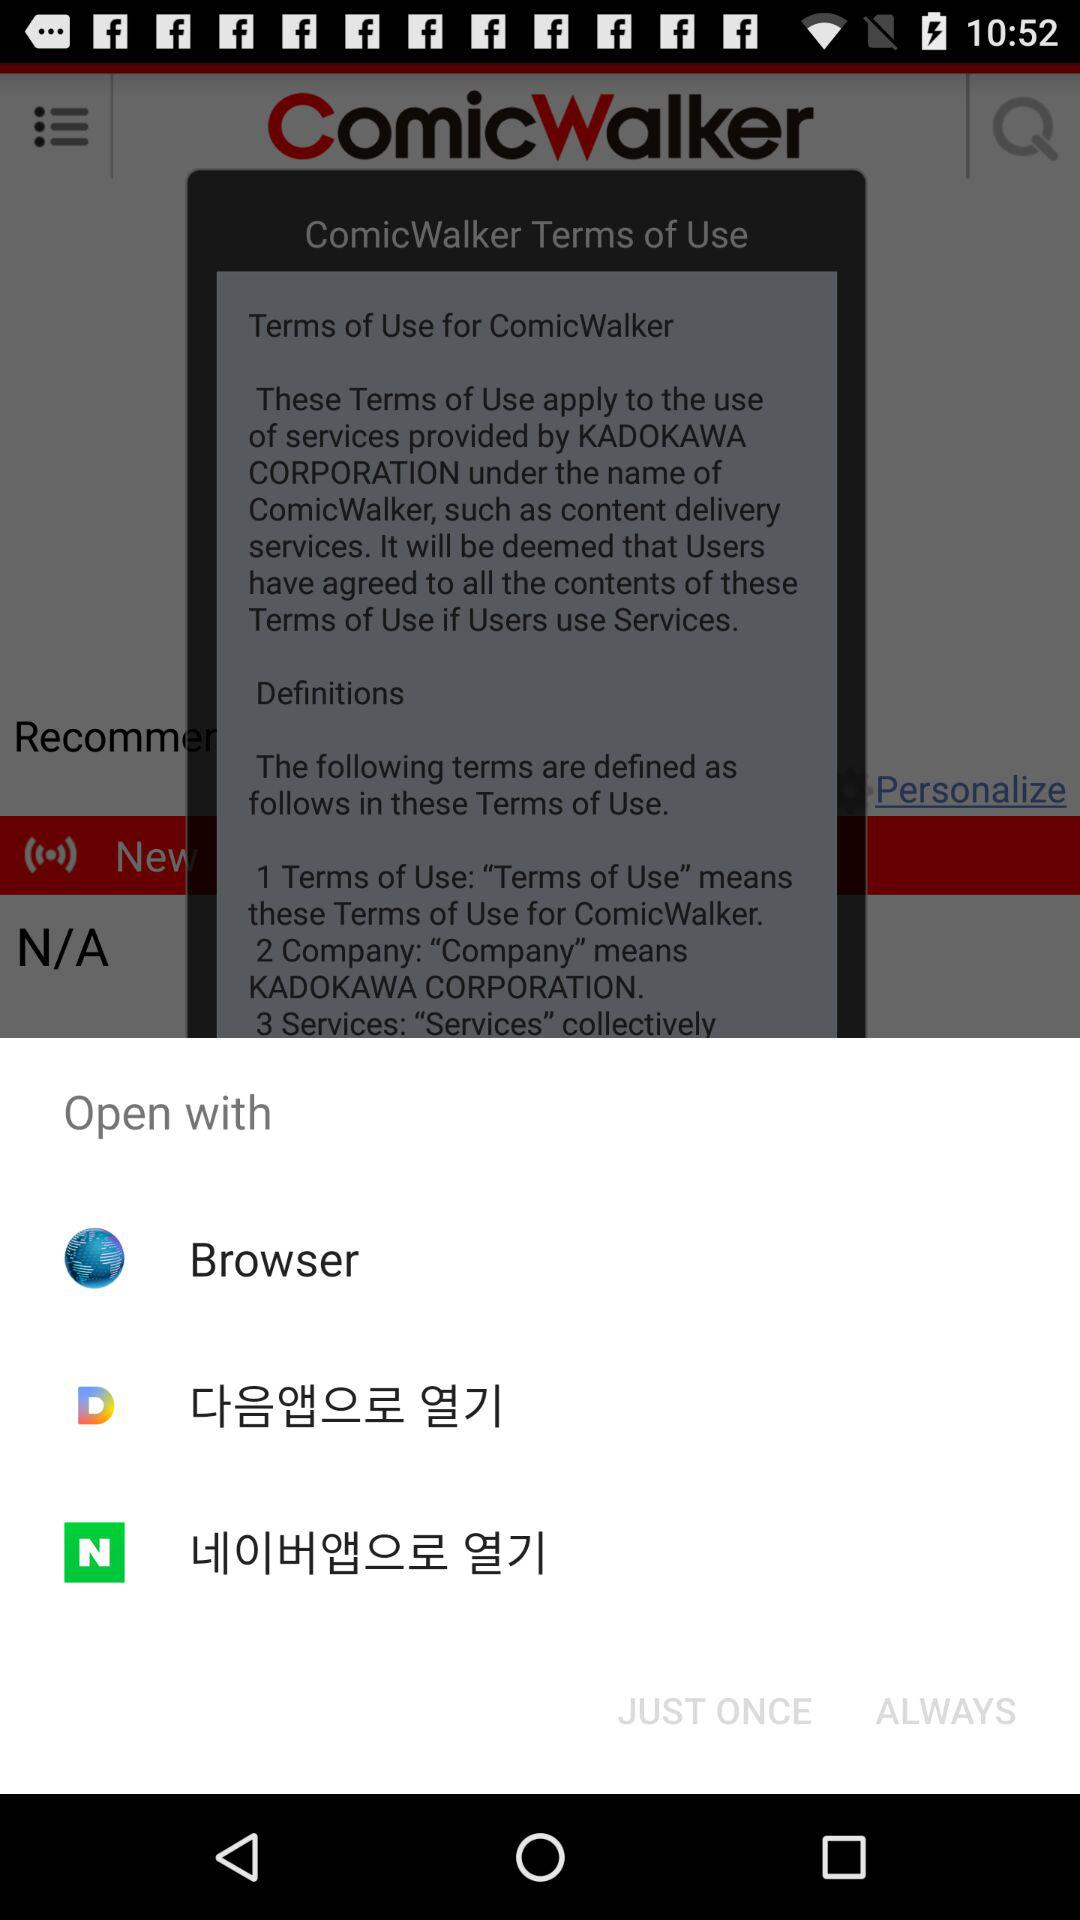How many open with options are there?
Answer the question using a single word or phrase. 3 